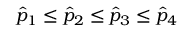Convert formula to latex. <formula><loc_0><loc_0><loc_500><loc_500>\hat { p } _ { 1 } \leq \hat { p } _ { 2 } \leq \hat { p } _ { 3 } \leq \hat { p } _ { 4 }</formula> 